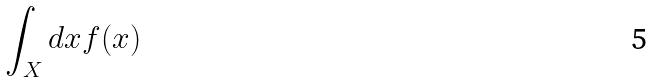<formula> <loc_0><loc_0><loc_500><loc_500>\int _ { X } d x f ( x )</formula> 